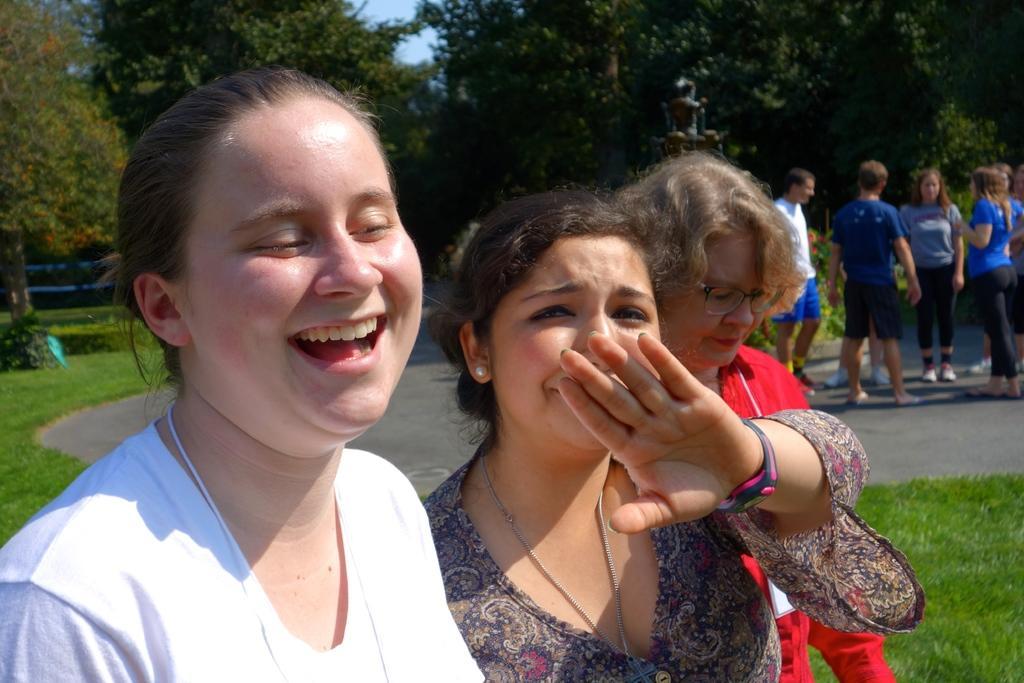How would you summarize this image in a sentence or two? Here we can see people. This woman is smiling. Background we can see trees, sky and grass. 